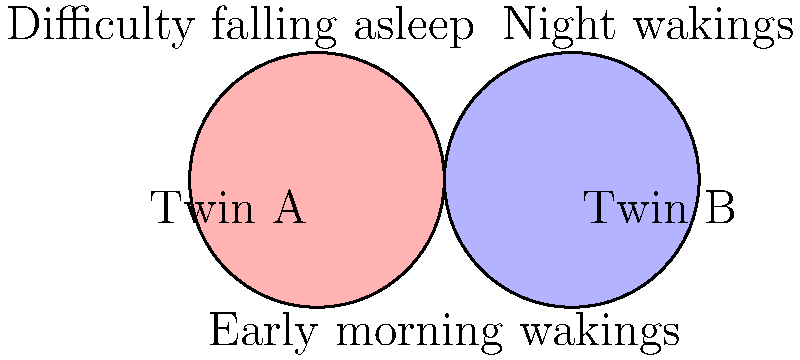Based on the Venn diagram illustrating sleep-related issues for twins, which problem is common to both Twin A and Twin B? To answer this question, we need to analyze the Venn diagram:

1. The left circle (pink) represents Twin A's sleep issues.
2. The right circle (blue) represents Twin B's sleep issues.
3. The overlapping area in the middle represents issues common to both twins.

We can see three main issues labeled in the diagram:
- "Difficulty falling asleep" is in Twin A's circle only.
- "Night wakings" is in Twin B's circle only.
- "Early morning wakings" is in the overlapping area of both circles.

Therefore, the problem that is common to both Twin A and Twin B is early morning wakings, as it appears in the intersection of both circles in the Venn diagram.
Answer: Early morning wakings 